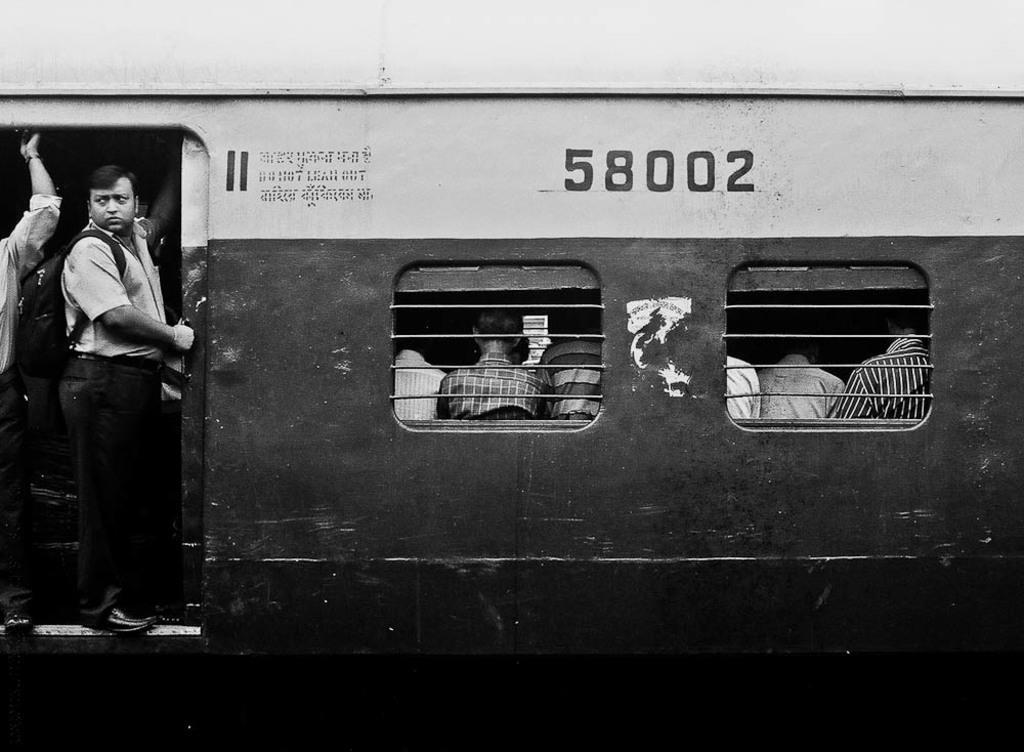Could you give a brief overview of what you see in this image? In this image we can see a black and white picture of a train wagon. To the left side of the image we can see group of persons standing. One person is carrying a bag. In the center we can see two windows and some person sitting. 